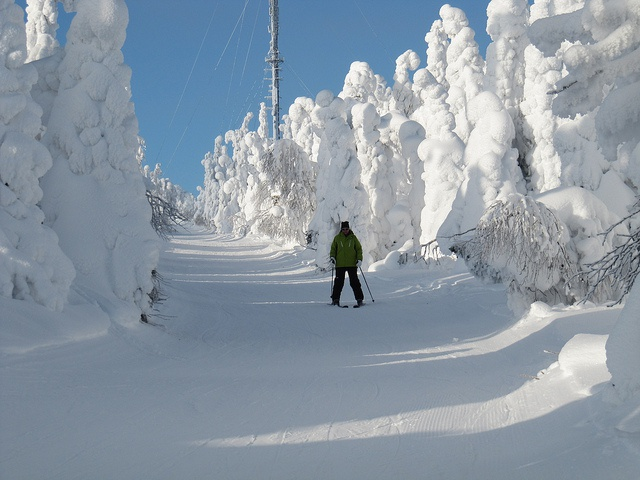Describe the objects in this image and their specific colors. I can see people in gray, black, darkgreen, and darkgray tones and skis in gray, black, and darkblue tones in this image. 